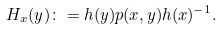<formula> <loc_0><loc_0><loc_500><loc_500>H _ { x } ( y ) \colon = h ( y ) p ( x , y ) h ( x ) ^ { - 1 } .</formula> 